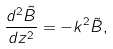<formula> <loc_0><loc_0><loc_500><loc_500>\frac { d ^ { 2 } \tilde { B } } { d z ^ { 2 } } = - k ^ { 2 } \tilde { B } ,</formula> 